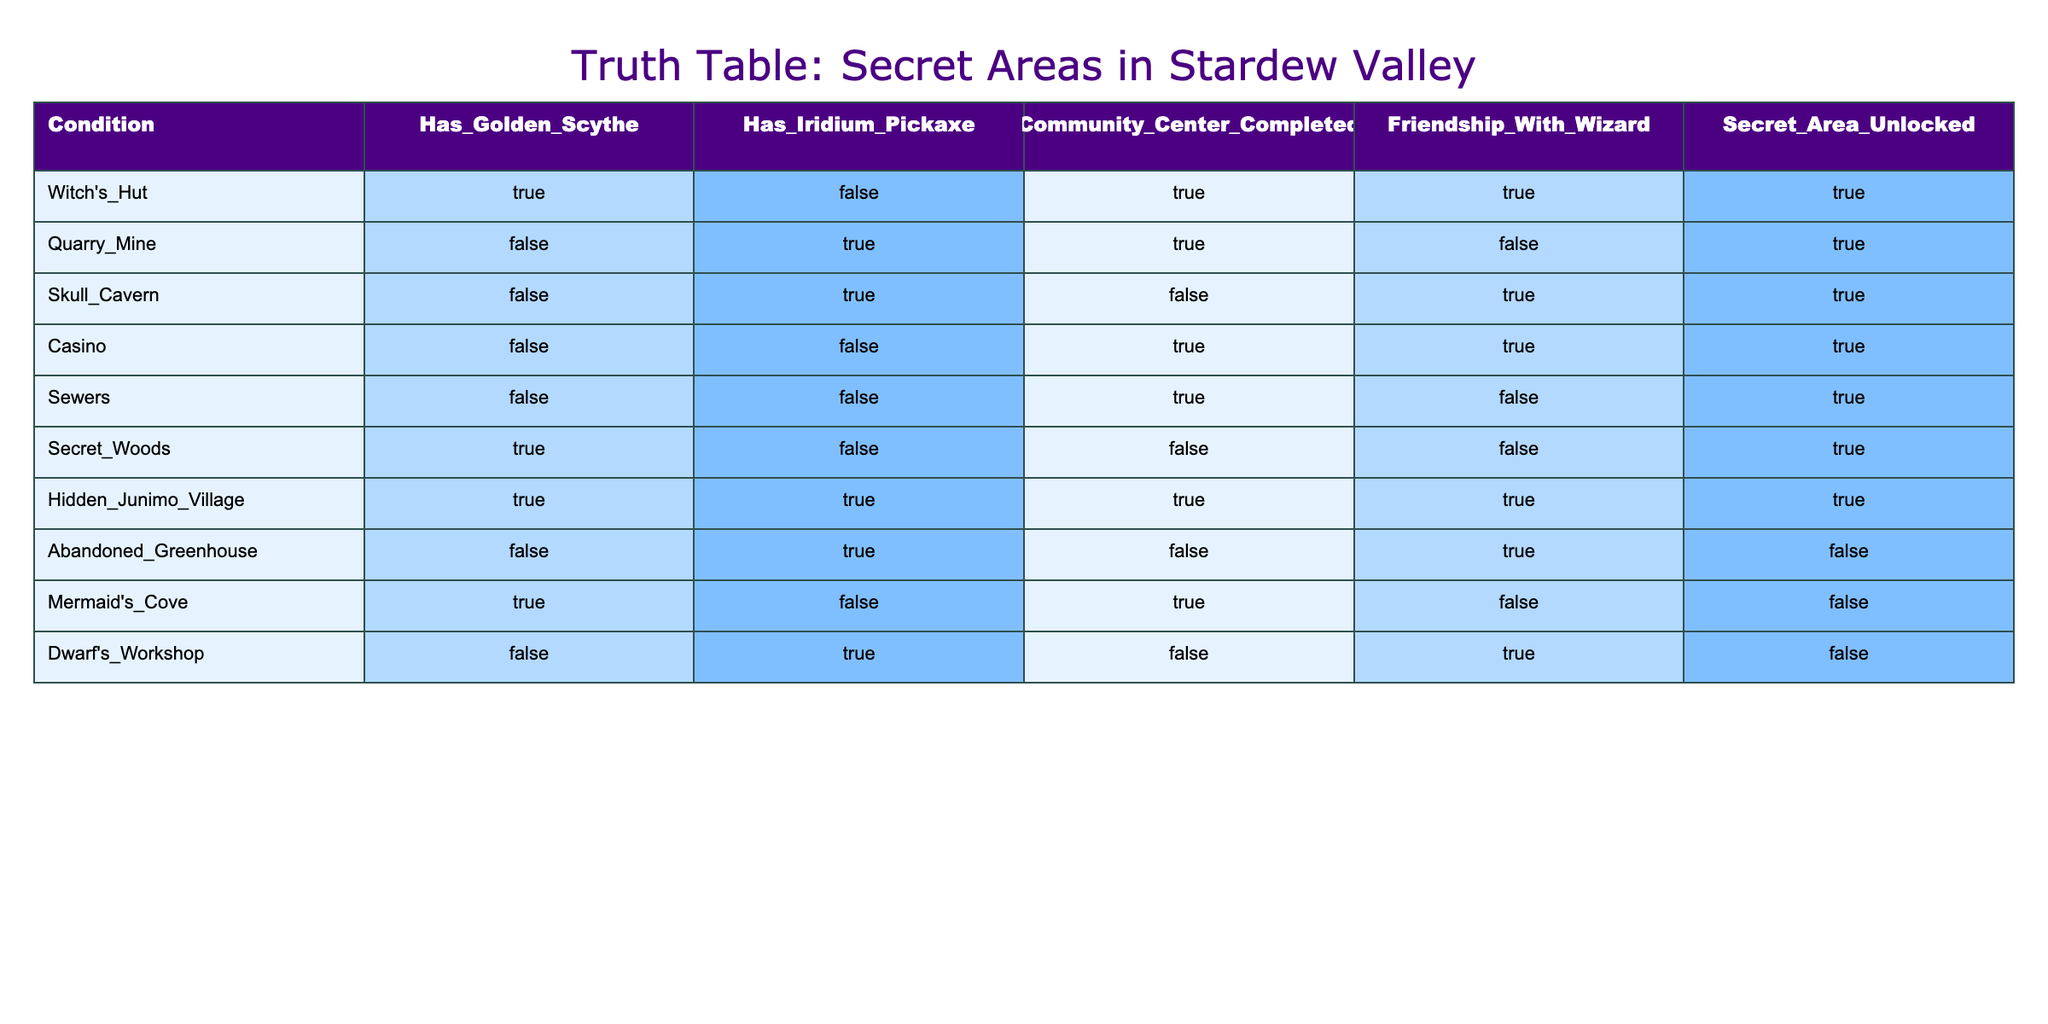What areas can be accessed if the player has the Golden Scythe? The table shows that the Witch's Hut and the Secret Woods are accessible with the Golden Scythe. Both areas have "TRUE" in the "Has_Golden_Scythe" column.
Answer: Witch's Hut and Secret Woods Is the Abandoned Greenhouse accessible if the player has an Iridium Pickaxe? The table indicates that the Abandoned Greenhouse is not accessible with an Iridium Pickaxe as it has "FALSE" under the "Secret_Area_Unlocked" column despite having "TRUE" in the "Has_Iridium_Pickaxe" column.
Answer: No What is the total number of areas that can be accessed after completing the Community Center? By checking the "Community_Center_Completed" column against the "Secret_Area_Unlocked" column, the accessible areas are: Witch's Hut, Quarry Mine, Casino, Sewers, and Mermaid's Cove. This adds up to a total of 5 areas.
Answer: 5 Which areas require friendship with the Wizard for access? The areas that require friendship with the Wizard are the Witch's Hut, Skull Cavern, and Casino, as these have "TRUE" in the "Friendship_With_Wizard" column and are also marked as "TRUE" for the "Secret_Area_Unlocked."
Answer: Witch's Hut, Skull Cavern, Casino Are there any areas that can be accessed without having either the Golden Scythe or Iridium Pickaxe? The table shows that the Quarry Mine, Skull Cavern, Casino, and Sewers can be accessed without these tools, as they have "FALSE" for the "Has_Golden_Scythe" and "Has_Iridium_Pickaxe" columns but still have "TRUE" in the "Secret_Area_Unlocked" column.
Answer: Yes, 4 areas What is the only area that requires both a Golden Scythe and an Iridium Pickaxe to be accessed? The Hidden Junimo Village is the only area that indicates the need for both the Golden Scythe and Iridium Pickaxe, as both conditions are marked "TRUE" and it is also marked "TRUE" for area access.
Answer: Hidden Junimo Village How many areas can be accessed with no requirements met (all FALSE)? From the table, all areas are marked "TRUE" for at least one condition except the Abandoned Greenhouse and Mermaid's Cove, which have no access despite some conditions being met. However, none is fully accessible with no requirements met.
Answer: 0 Is it possible to access the Secret Woods if the Community Center is not completed? The table indicates that the Secret Woods can still be accessed independently of the Community Center, as it is marked "TRUE" for being unlocked despite the Community Center being "FALSE."
Answer: Yes 